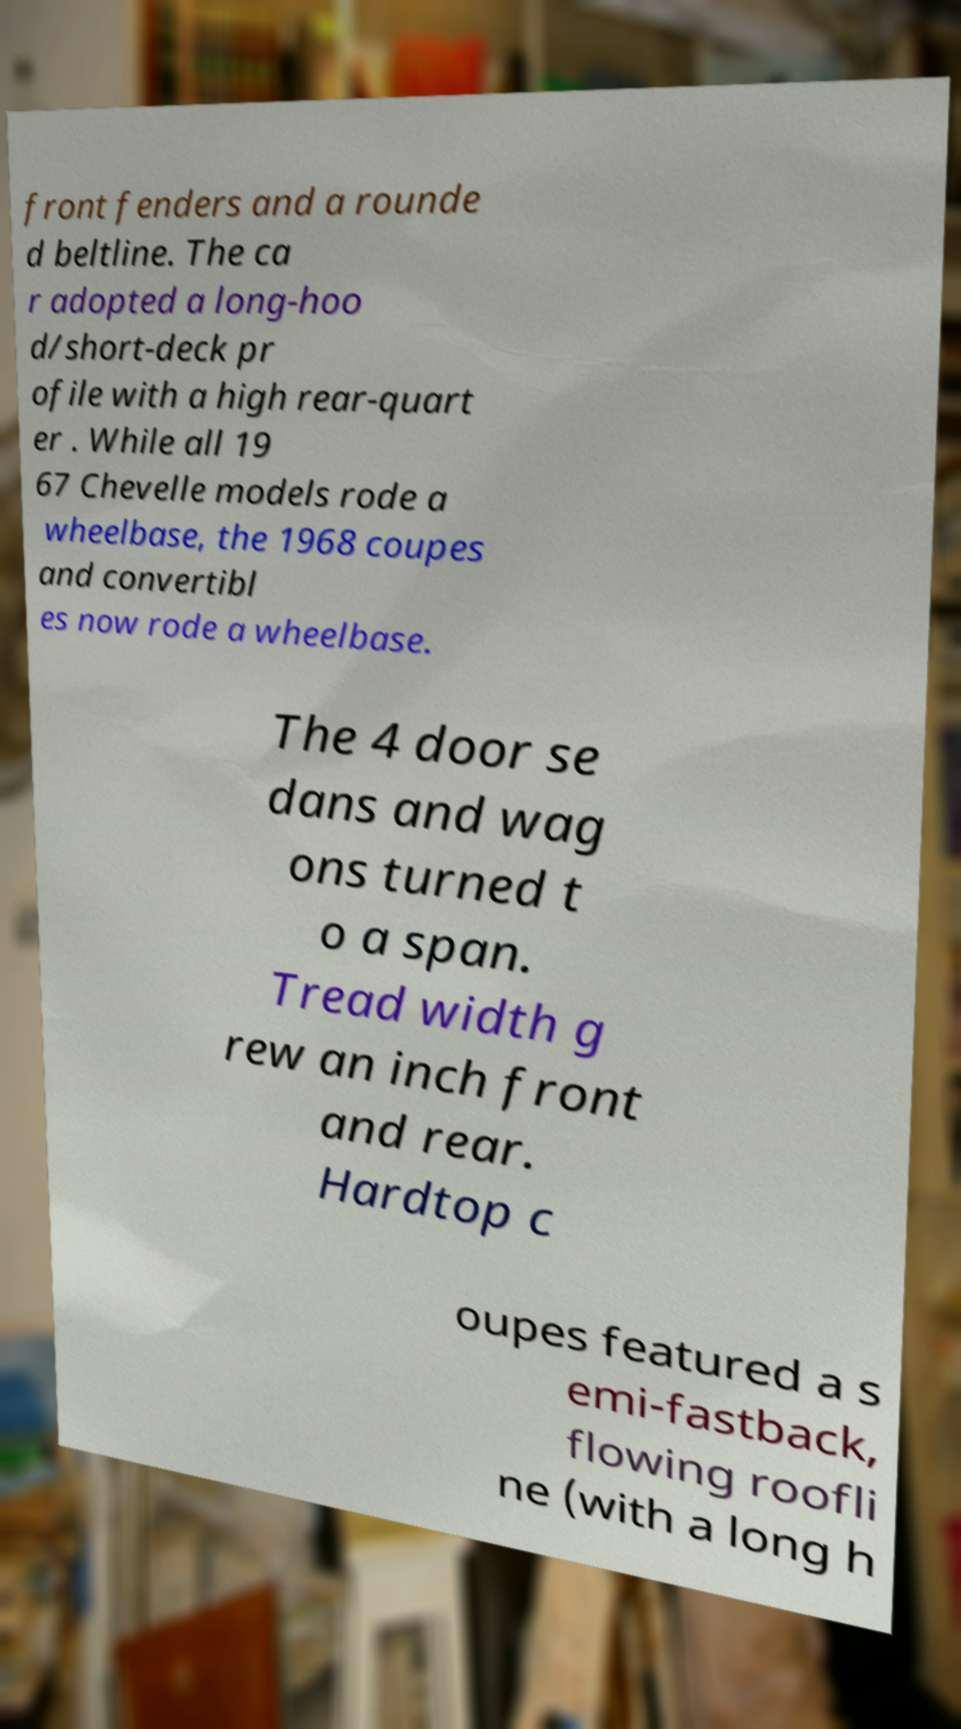Please read and relay the text visible in this image. What does it say? front fenders and a rounde d beltline. The ca r adopted a long-hoo d/short-deck pr ofile with a high rear-quart er . While all 19 67 Chevelle models rode a wheelbase, the 1968 coupes and convertibl es now rode a wheelbase. The 4 door se dans and wag ons turned t o a span. Tread width g rew an inch front and rear. Hardtop c oupes featured a s emi-fastback, flowing roofli ne (with a long h 